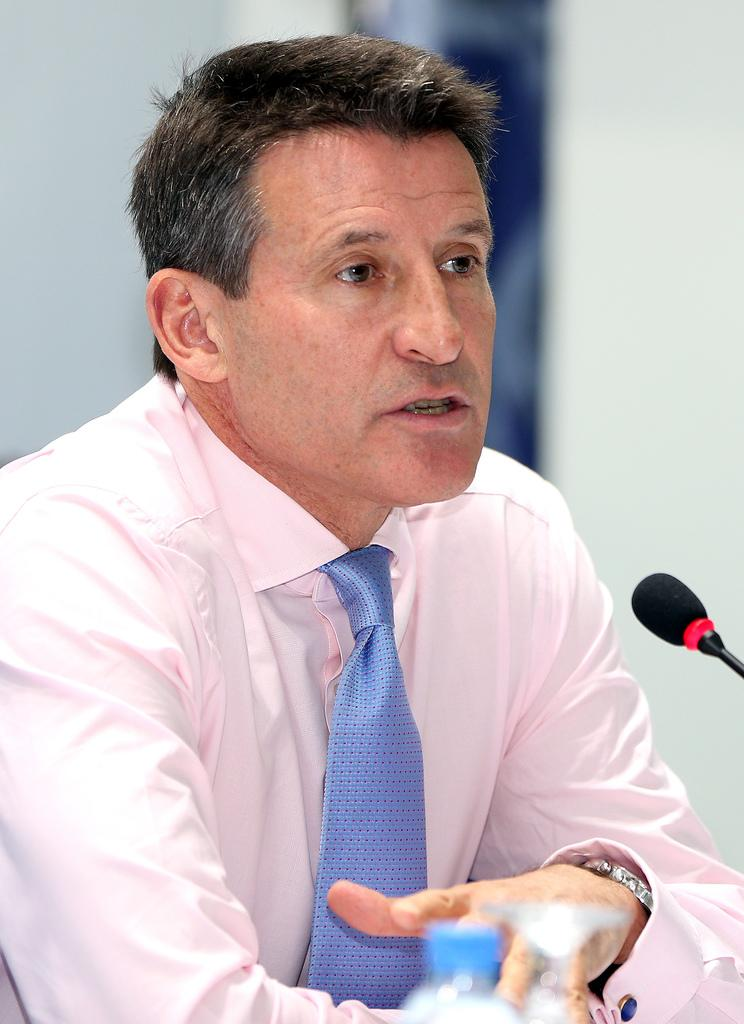What is the main subject of the image? There is a person in the image. What object is visible near the person? There is a microphone in the image. What else can be seen in the image besides the person and the microphone? There is a water bottle in the image. How many sheep are visible in the image? There are no sheep present in the image. What type of girls are featured in the image? There are no girls present in the image. 